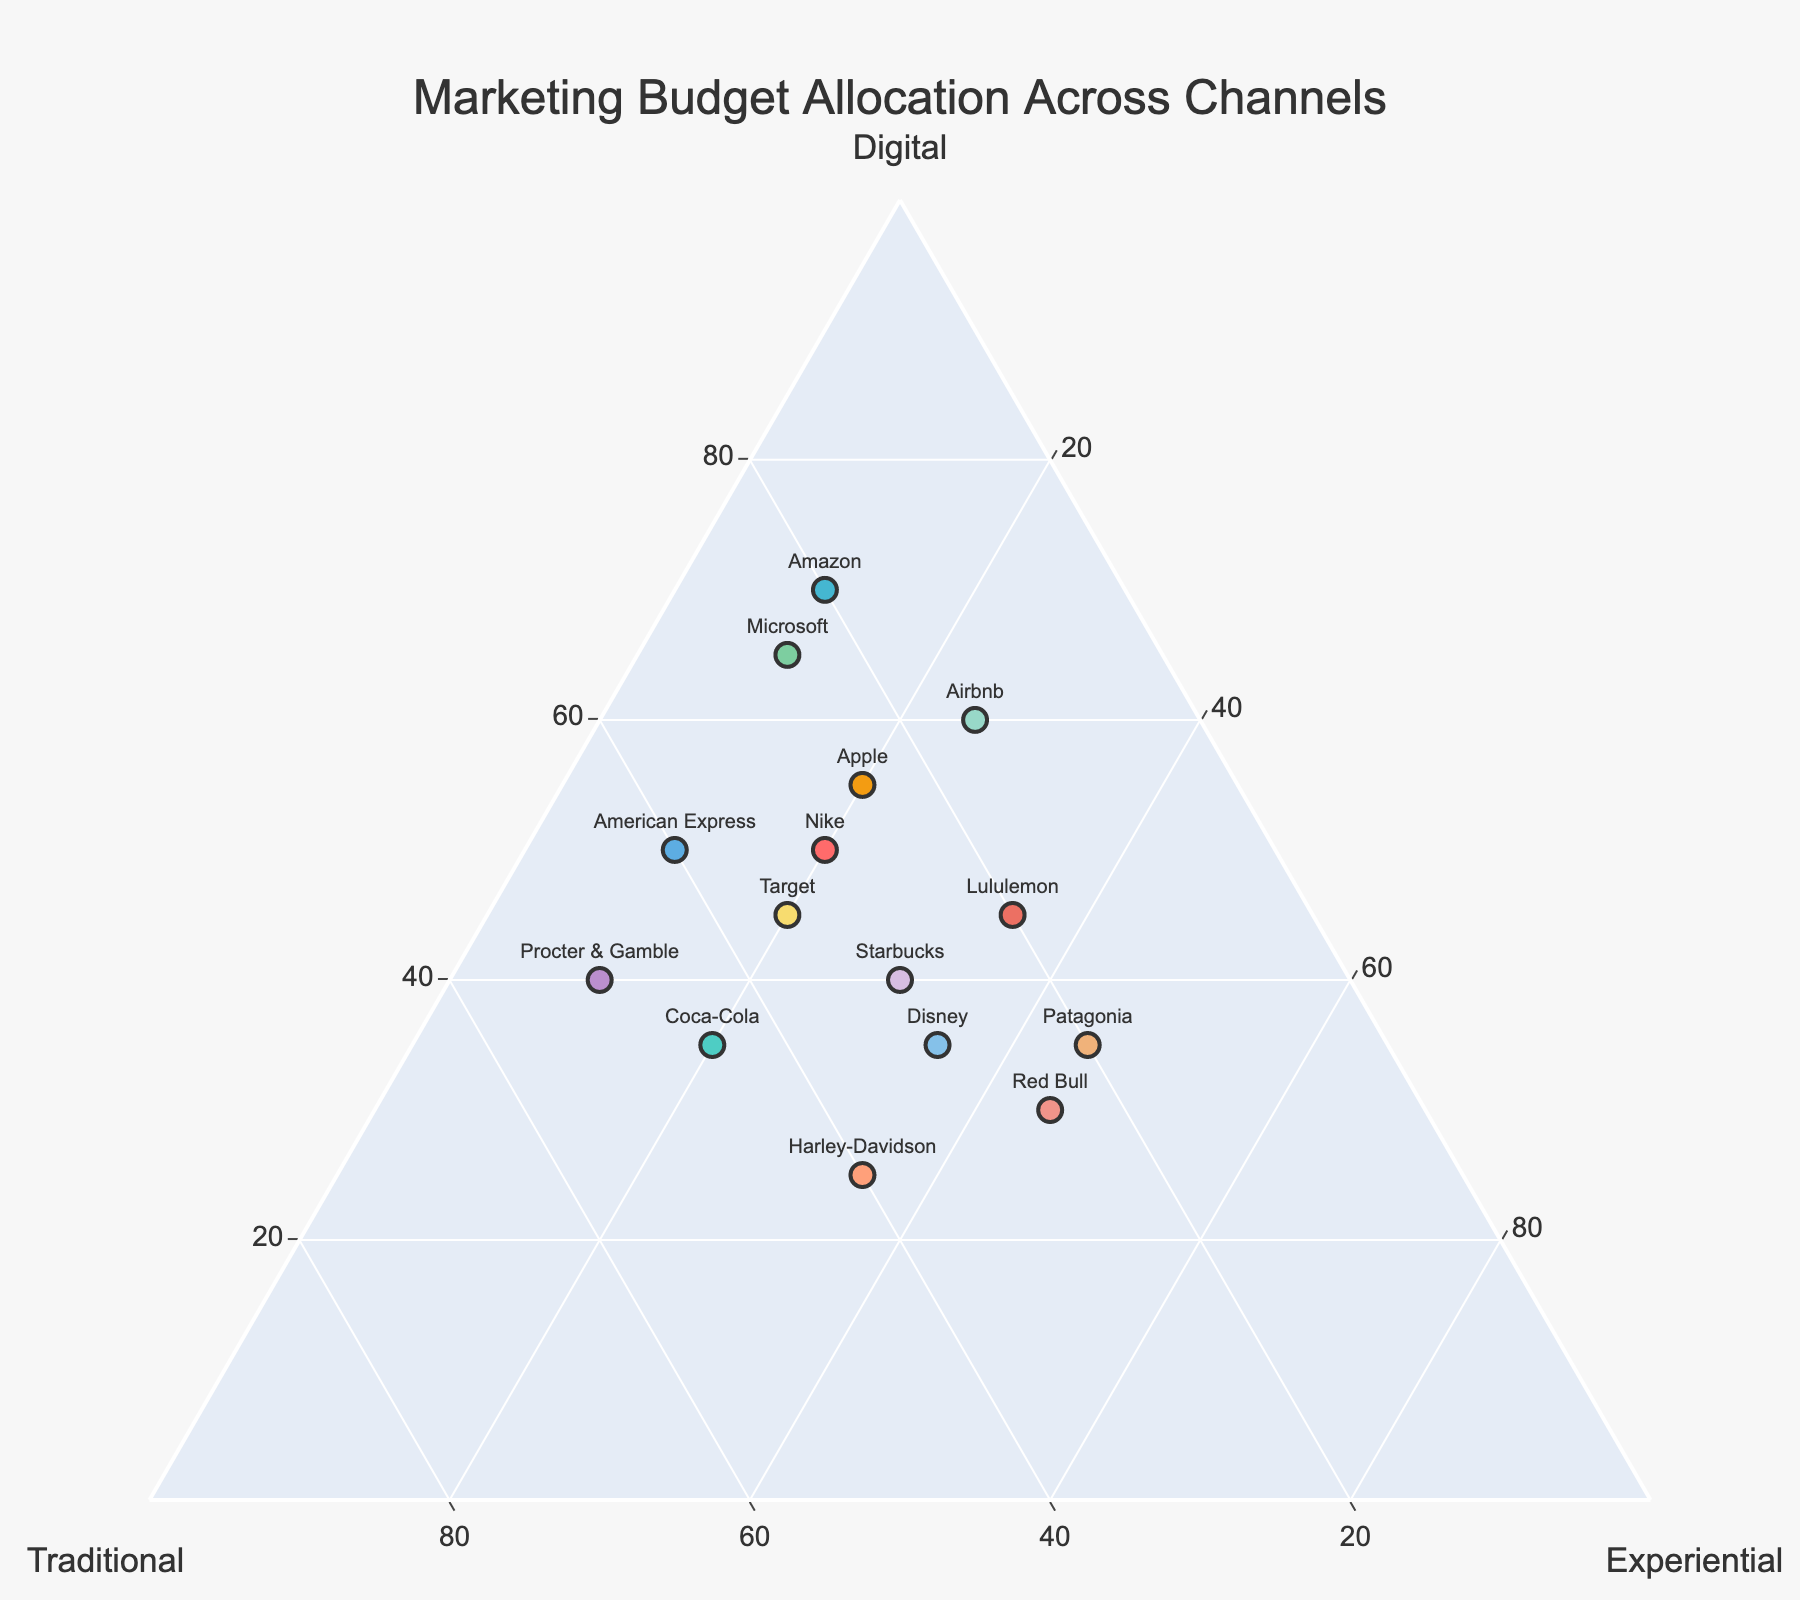How many companies allocate the highest percentage of their marketing budget to digital channels? Check the data points in the ternary plot to see which companies fall on the "Digital" axis's higher values. There are four companies, Amazon, Airbnb, Microsoft, and Apple, that have the highest allocation in digital.
Answer: 4 Which company has the highest allocation in experiential channels? Identify the data point that is closest to the "Experiential" axis. Red Bull and Patagonia are close in their allocations, Red Bull being at 45%.
Answer: Red Bull What is the total marketing budget allocation for Coca-Cola on traditional and experiential channels? Sum the values for traditional and experiential channels for Coca-Cola. Traditional is 45 and experiential is 20, so 45 + 20 = 65.
Answer: 65 Which company has an equal percentage of allocation between digital and experiential channels? Look for points where the values for digital and experiential channels are the same. Disney and Starbucks have both 35% each in digital and experiential.
Answer: Disney or Starbucks Who allocates the least percentage to traditional channels? Identify the company with the smallest label near the "Traditional" axis. Airbnb and Lululemon have the lowest percentage in traditional channels at 15% and 20%, respectively.
Answer: Airbnb What is the average allocation in digital channels for all companies? Sum the digital allocation percentages and divide by the number of companies (15). Total sum: 50+35+70+25+60+45+40+30+35+55+40+65+35+50+45 = 680. Average = 680 / 15 = 45.33.
Answer: 45.33 Which company has nearly balanced allocations (almost equal in percentages) across all three channels? Check for points near the center of the ternary plot indicating a balance. Harley-Davidson and Disney are closest to having balanced allocations.
Answer: Harley-Davidson or Disney Which two companies spend exactly 10% on experiential channels? Identify the data points labeled with 10% near the "Experiential" axis. Procter & Gamble and American Express are the two companies.
Answer: Procter & Gamble and American Express 